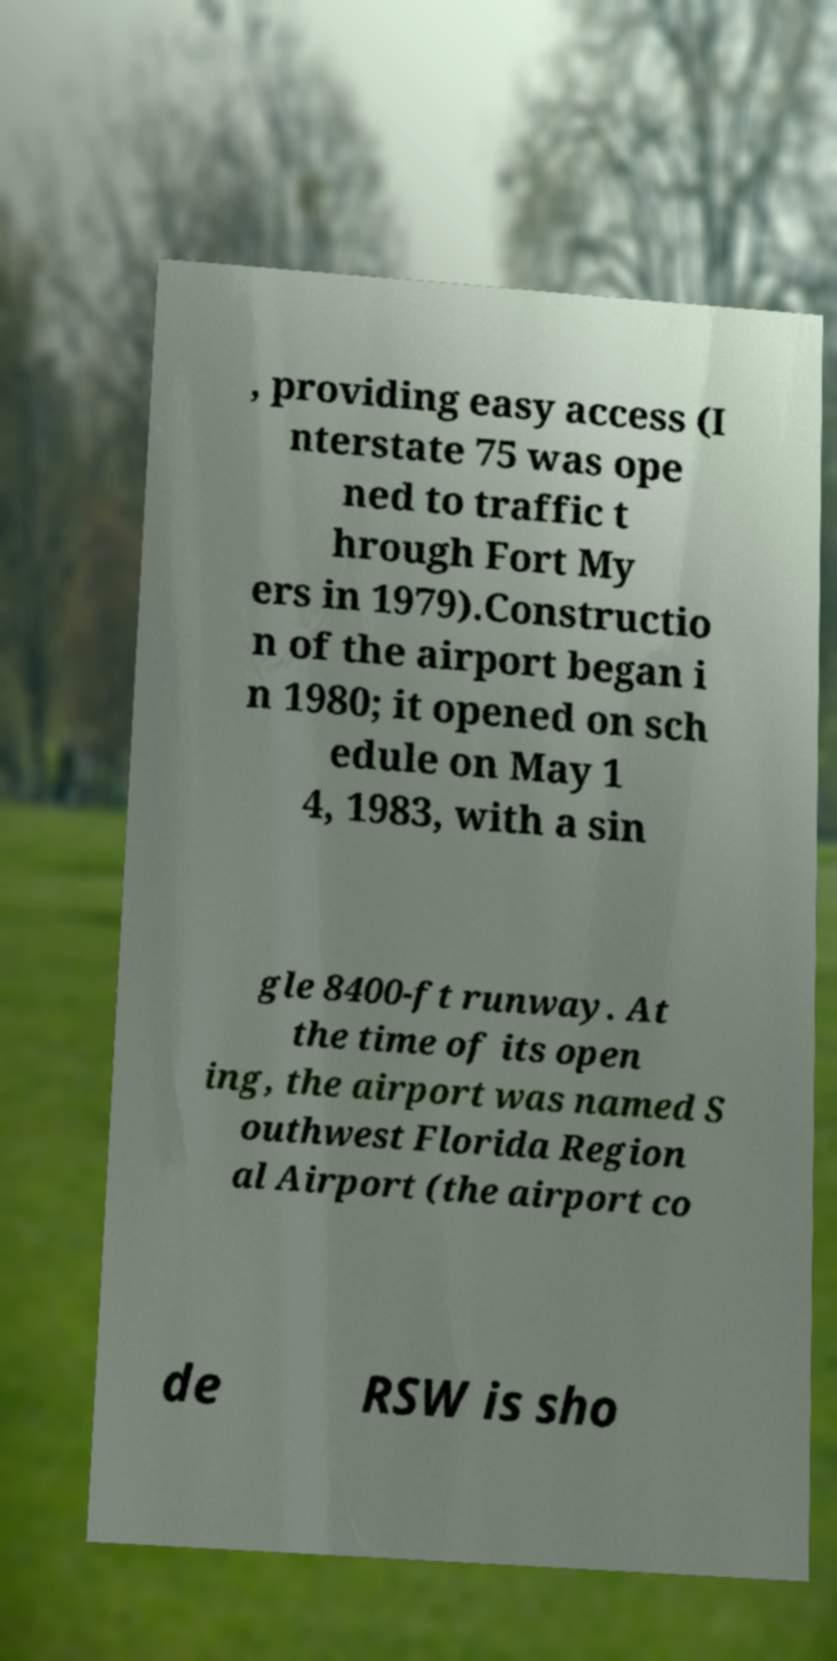Can you read and provide the text displayed in the image?This photo seems to have some interesting text. Can you extract and type it out for me? , providing easy access (I nterstate 75 was ope ned to traffic t hrough Fort My ers in 1979).Constructio n of the airport began i n 1980; it opened on sch edule on May 1 4, 1983, with a sin gle 8400-ft runway. At the time of its open ing, the airport was named S outhwest Florida Region al Airport (the airport co de RSW is sho 